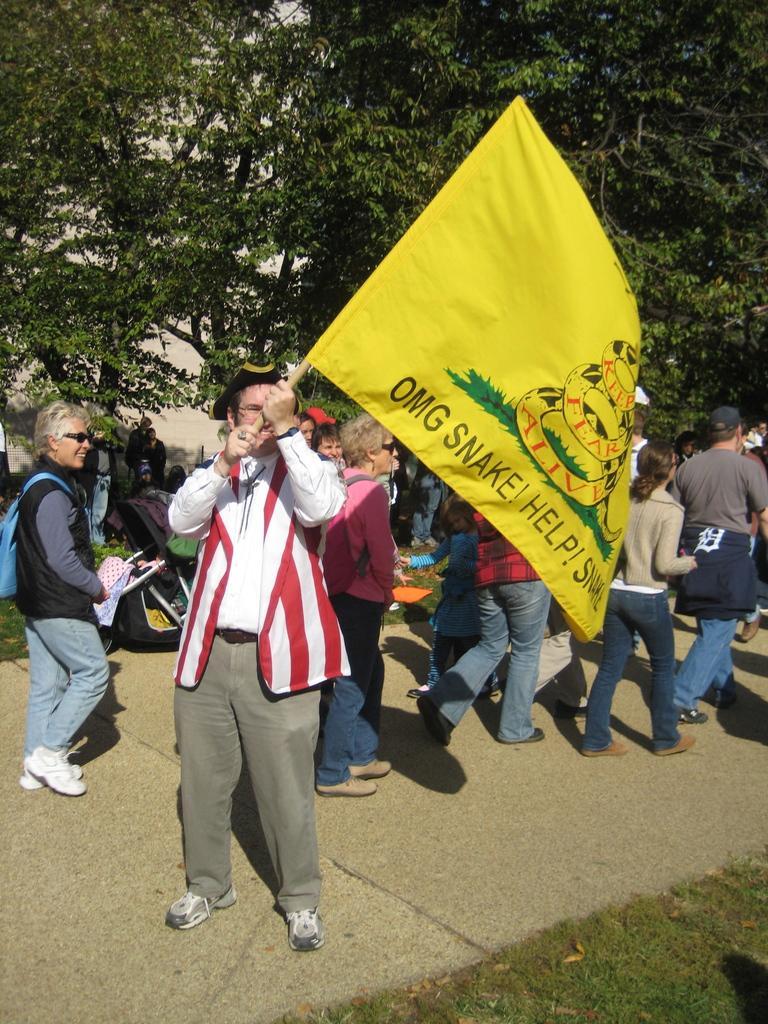In one or two sentences, can you explain what this image depicts? In this picture there is a man who is holding a yellow color flag. Behind him I can see some persons who are walking on the street. At the bottom I can see the green grass. In the background I can see the trees and building. In the left background I can see the trolley, dustbin, fencing and other objects. 